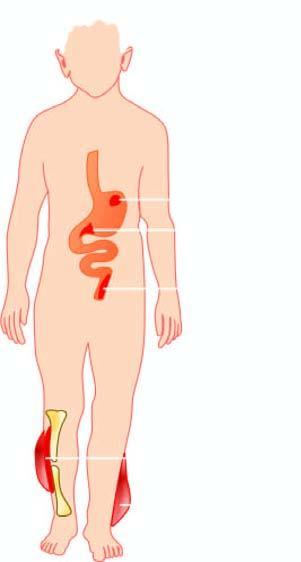what is diseases caused by?
Answer the question using a single word or phrase. Streptococci 